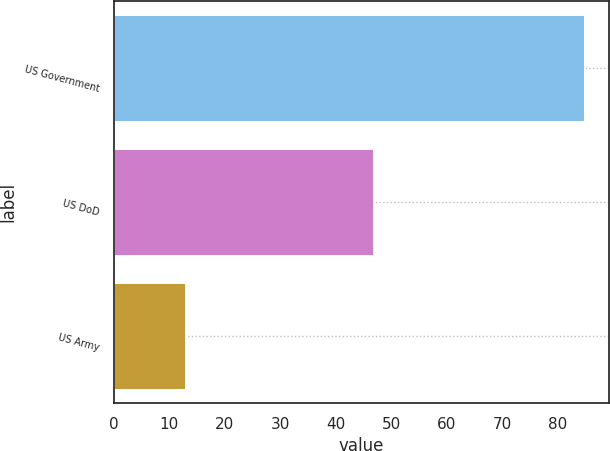Convert chart to OTSL. <chart><loc_0><loc_0><loc_500><loc_500><bar_chart><fcel>US Government<fcel>US DoD<fcel>US Army<nl><fcel>85<fcel>47<fcel>13<nl></chart> 